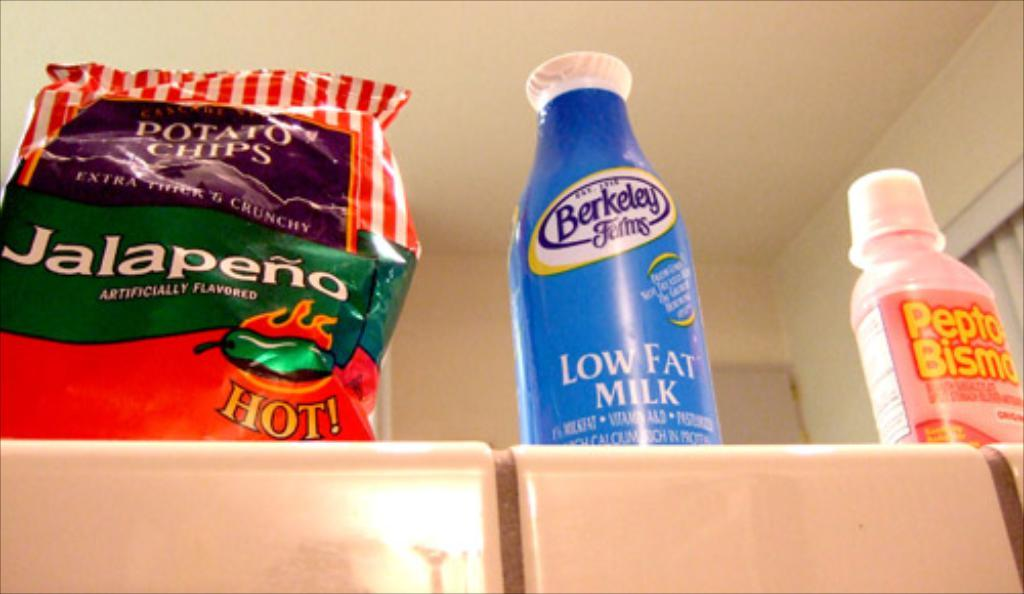<image>
Share a concise interpretation of the image provided. Low Fat milk sits inbetween pepto bismol and jalapeno chisp 